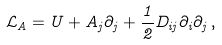<formula> <loc_0><loc_0><loc_500><loc_500>\mathcal { L } _ { A } = U + A _ { j } \partial _ { j } + \frac { 1 } { 2 } D _ { i j } \partial _ { i } \partial _ { j } \, ,</formula> 